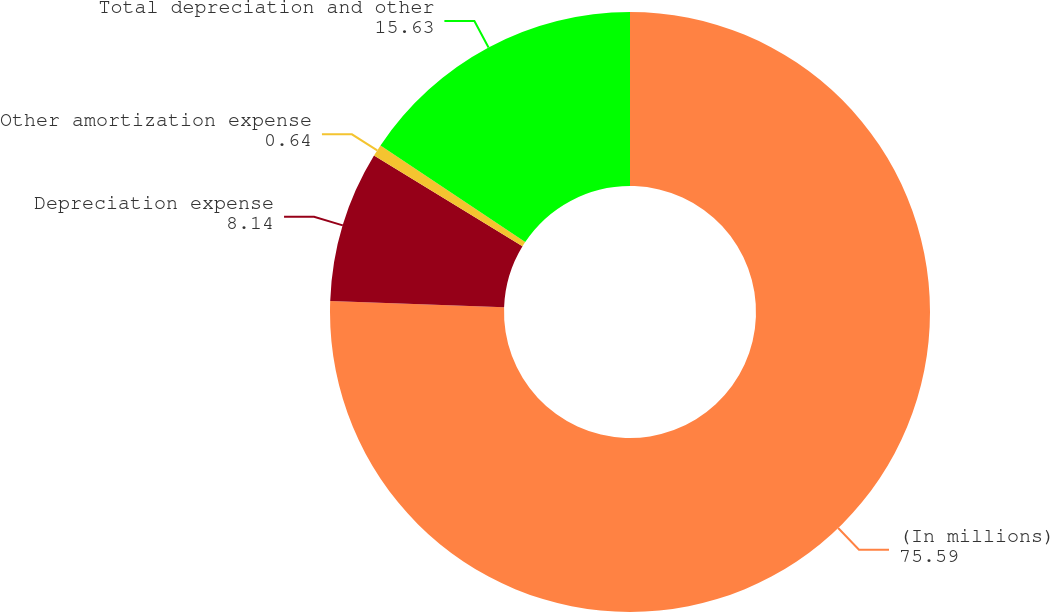Convert chart. <chart><loc_0><loc_0><loc_500><loc_500><pie_chart><fcel>(In millions)<fcel>Depreciation expense<fcel>Other amortization expense<fcel>Total depreciation and other<nl><fcel>75.59%<fcel>8.14%<fcel>0.64%<fcel>15.63%<nl></chart> 